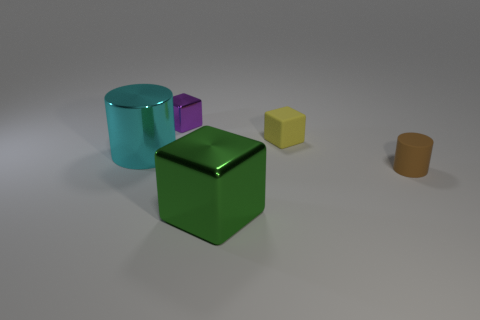What is the color of the cube that is on the right side of the object in front of the brown rubber cylinder?
Your answer should be very brief. Yellow. Are there fewer large green things behind the large cyan metallic object than tiny matte cylinders behind the brown rubber object?
Your response must be concise. No. Do the shiny cylinder and the matte cylinder have the same size?
Give a very brief answer. No. The metallic thing that is both in front of the purple object and right of the big cyan cylinder has what shape?
Make the answer very short. Cube. What number of big green things are the same material as the small yellow cube?
Keep it short and to the point. 0. There is a cylinder left of the small yellow rubber object; how many small yellow objects are in front of it?
Provide a short and direct response. 0. There is a big metallic object that is to the right of the metal object behind the big object that is behind the small brown object; what shape is it?
Give a very brief answer. Cube. How many things are either tiny purple blocks or brown matte blocks?
Provide a short and direct response. 1. What color is the other cube that is the same size as the yellow block?
Your response must be concise. Purple. There is a tiny purple metal object; is it the same shape as the large cyan metal object that is behind the small brown rubber thing?
Your answer should be compact. No. 